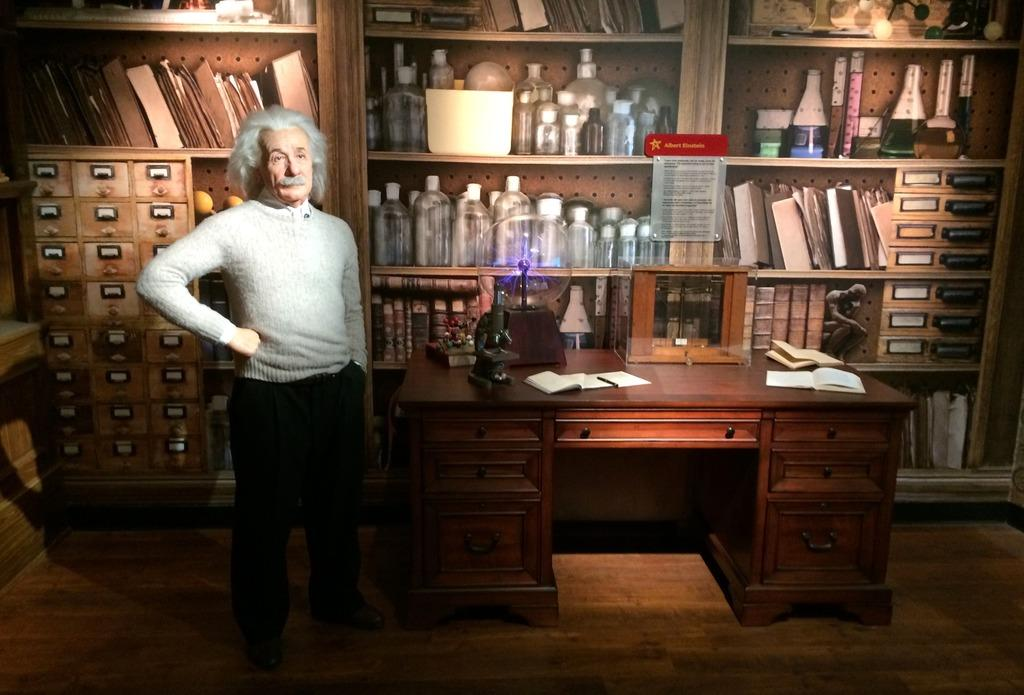What is the main subject in the image? There is a person standing in the image. What can be seen behind the person? There is a wooden shelf in the image, which has many things placed on it. What is on the table in the image? There is a microscope on the table in the image. Can you describe the wooden shelf in the image? The wooden shelf has many things placed on it, indicating that it might be used for storage or display. How many brothers does the governor have in the image? There is no governor or mention of brothers in the image. The image features a person standing, a wooden shelf, a table, and a microscope. 